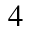<formula> <loc_0><loc_0><loc_500><loc_500>4</formula> 